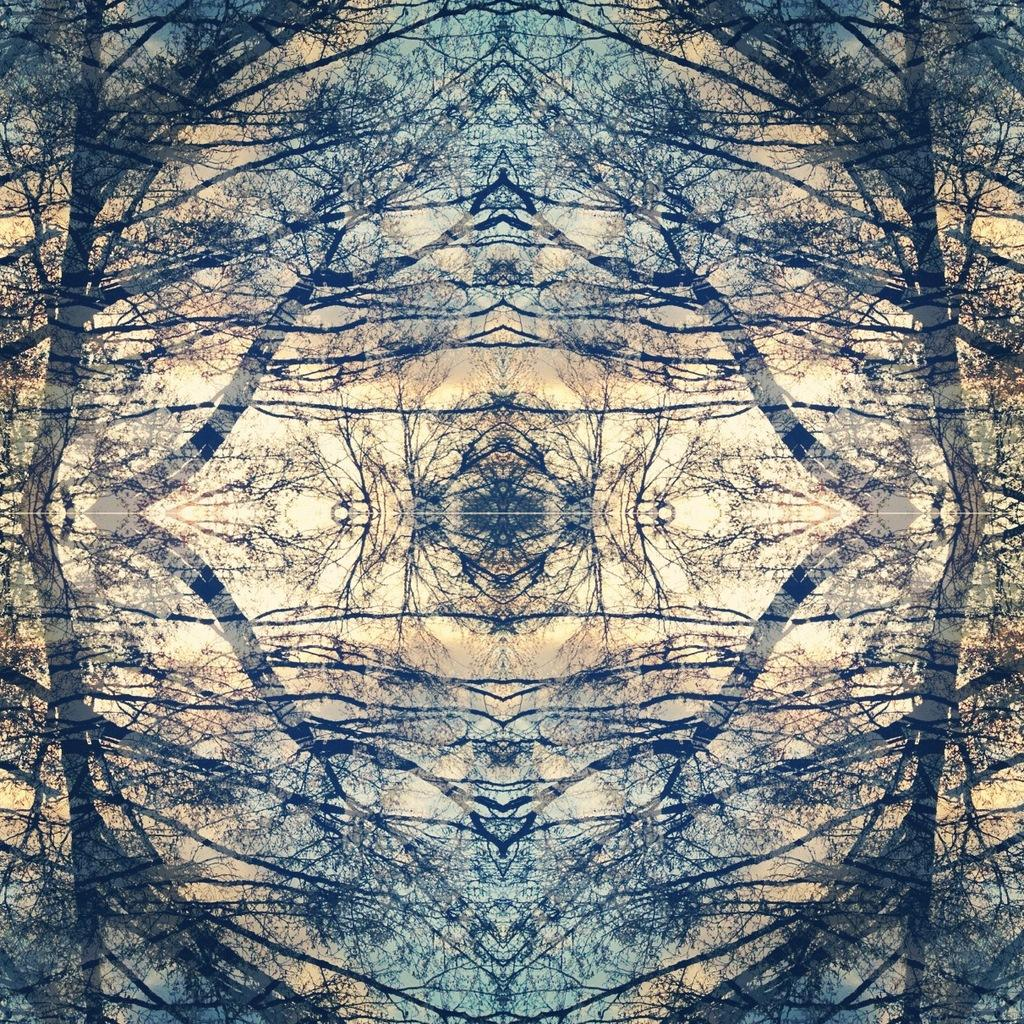What type of object is the main focus of the image? The image contains an art piece. What is depicted in the art piece? The art piece features a tree. Are there any additional elements surrounding the art piece? Yes, there are mirrored images on either side of the art piece. What colors are used in the art piece? The art piece includes blue and cream colors. What type of scarf is draped over the tree in the art piece? There is no scarf draped over the tree in the art piece; it only features a tree and colors. Can you see any insects crawling on the tree in the art piece? There are no insects visible on the tree in the art piece; it only features a tree and colors. 